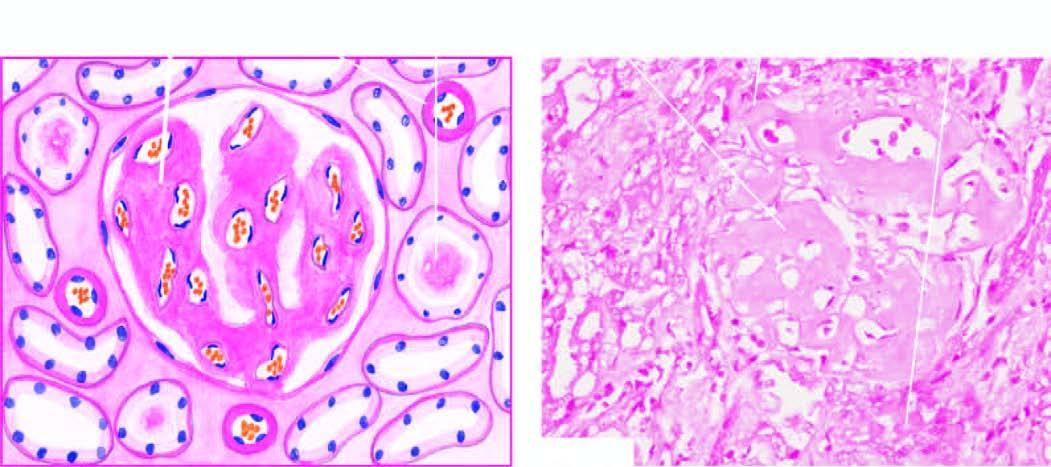re the deposits also present in peritubular connective tissue producing atrophic tubules?
Answer the question using a single word or phrase. Yes 